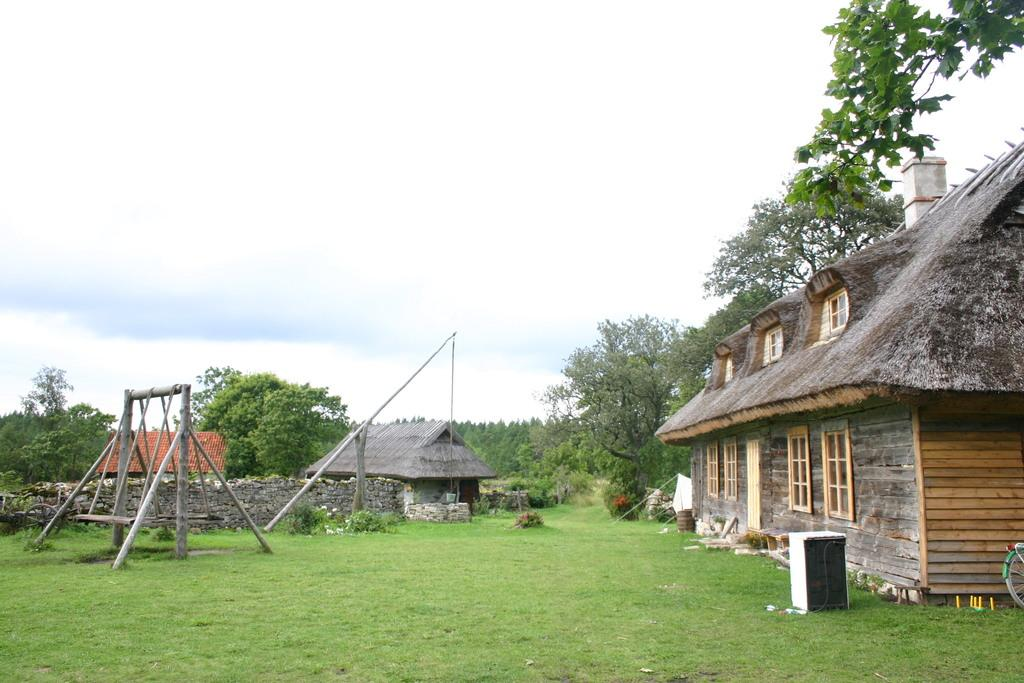What type of structures can be seen in the image? There are sheds in the image. Where is the swing located in the image? The swing is on the left side of the image. What can be seen in the background of the image? There are trees and the sky visible in the background of the image. What caused the deer to jump over the shed in the image? There are no deer present in the image, so it is not possible to determine the cause of any jumping. 